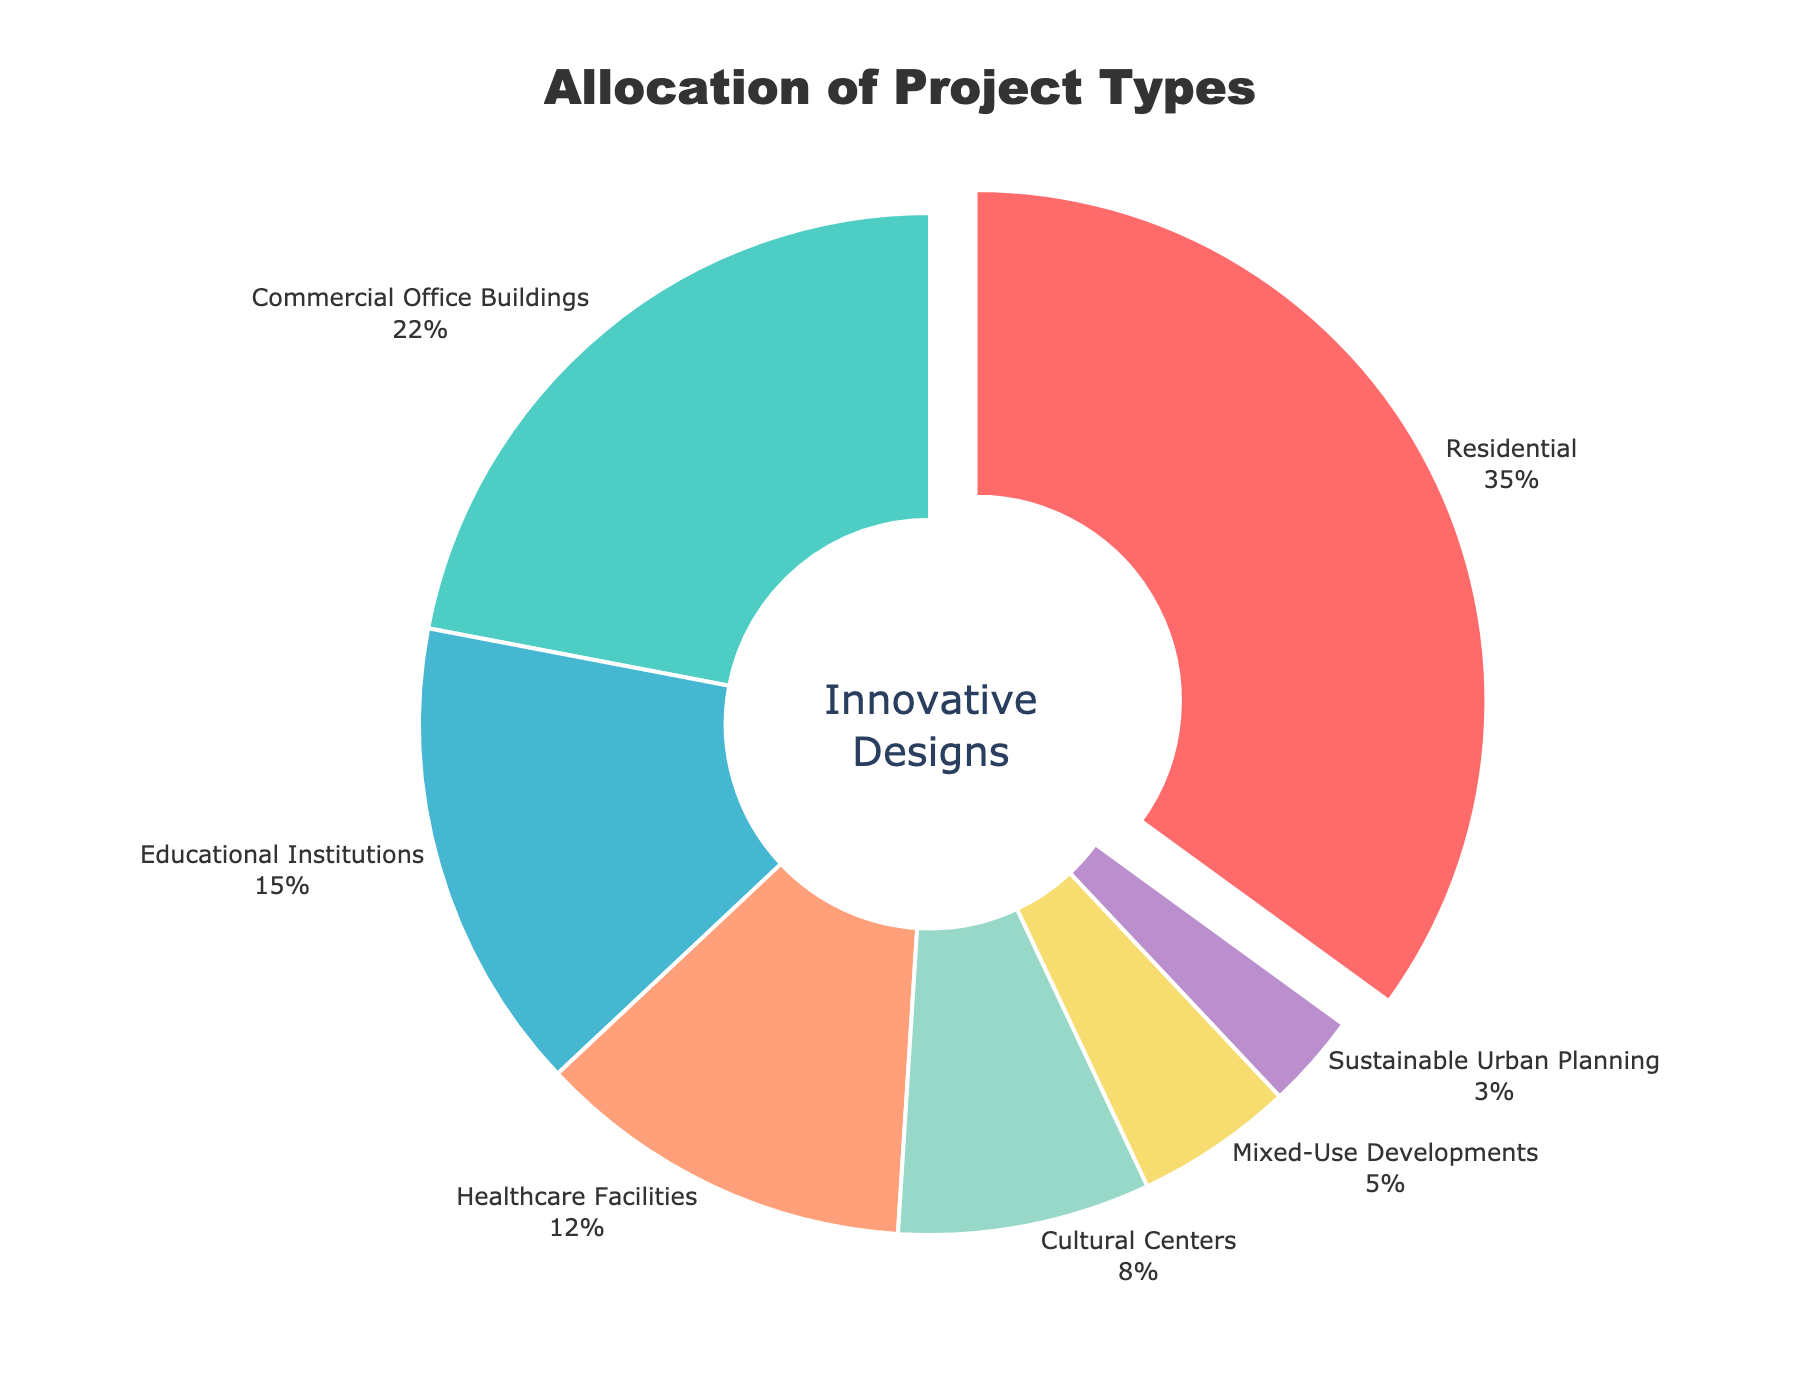What is the percentage of Residential projects? The chart shows "Residential" as a segment with a label. By reading this label, we see it lists 35%.
Answer: 35% Which project type has the smallest allocation? By observing the chart, we see "Sustainable Urban Planning" is the smallest segment, visually identified as having 3%
Answer: Sustainable Urban Planning How much larger is the percentage of Commercial Office Buildings compared to Mixed-Use Developments? "Commercial Office Buildings" is 22%, and "Mixed-Use Developments" is 5%. The difference is 22% - 5% = 17%
Answer: 17% Which project types together account for more than half of the total allocation? Residential (35%) + Commercial Office Buildings (22%) = 57%, and this combination exceeds 50% of the pie chart.
Answer: Residential and Commercial Office Buildings What is the third largest project type in terms of allocation? The chart shows "Residential" (35%), "Commercial Office Buildings" (22%), followed by "Educational Institutions" (15%) as the third largest slice.
Answer: Educational Institutions How does the percentage of Cultural Centers compare with that of Healthcare Facilities? Cultural Centers account for 8%, and Healthcare Facilities account for 12%. By comparing these, we see Cultural Centers have a smaller percentage than Healthcare Facilities.
Answer: Cultural Centers have a smaller percentage than Healthcare Facilities If you combine the percentages of Healthcare Facilities and Cultural Centers, what is their total? Adding the percentages of "Healthcare Facilities" (12%) and "Cultural Centers" (8%), the total is 12% + 8% = 20%
Answer: 20% Which project type is represented by the red color in the pie chart? By observing the color coding in the chart, the red slice corresponds to "Residential"
Answer: Residential 